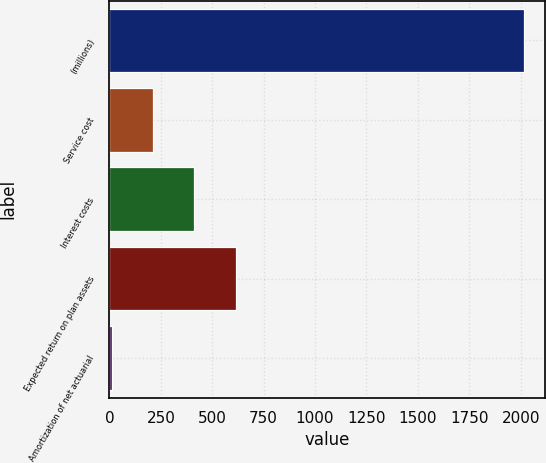Convert chart to OTSL. <chart><loc_0><loc_0><loc_500><loc_500><bar_chart><fcel>(millions)<fcel>Service cost<fcel>Interest costs<fcel>Expected return on plan assets<fcel>Amortization of net actuarial<nl><fcel>2016<fcel>212.94<fcel>413.28<fcel>613.62<fcel>12.6<nl></chart> 